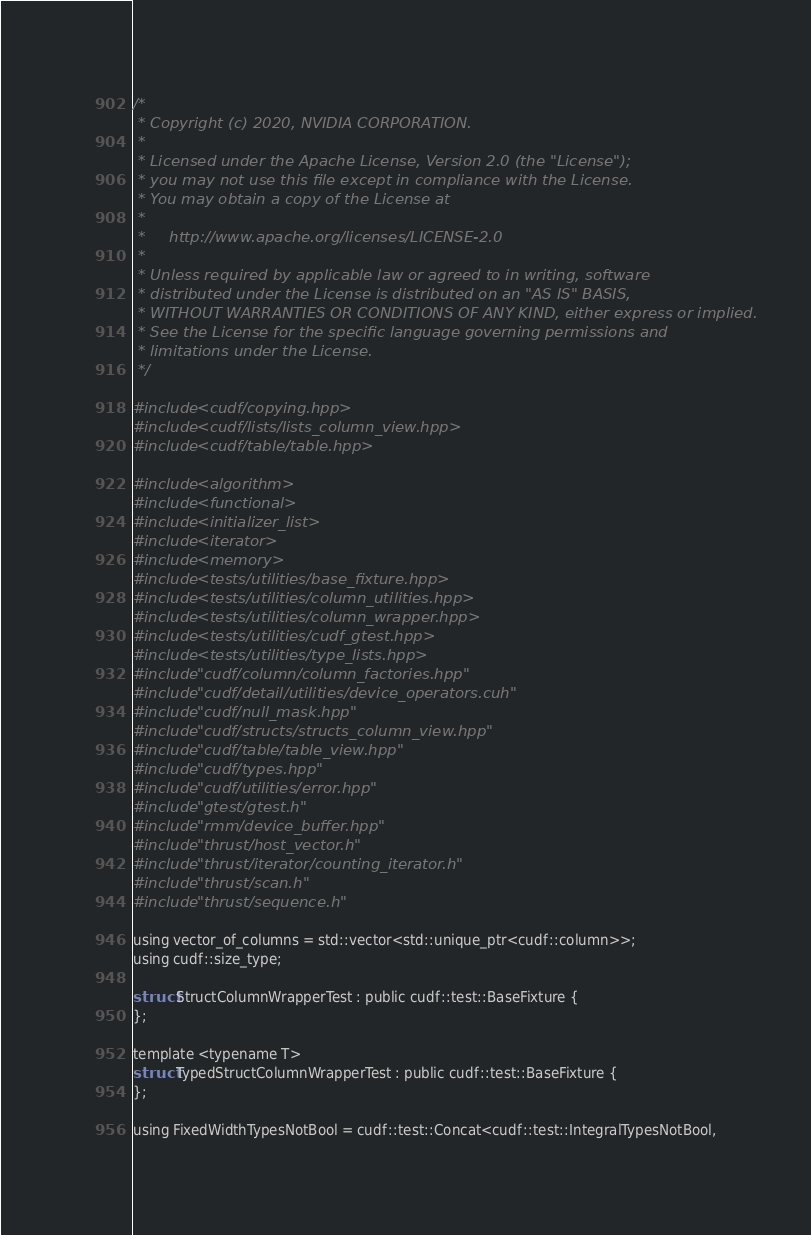Convert code to text. <code><loc_0><loc_0><loc_500><loc_500><_Cuda_>/*
 * Copyright (c) 2020, NVIDIA CORPORATION.
 *
 * Licensed under the Apache License, Version 2.0 (the "License");
 * you may not use this file except in compliance with the License.
 * You may obtain a copy of the License at
 *
 *     http://www.apache.org/licenses/LICENSE-2.0
 *
 * Unless required by applicable law or agreed to in writing, software
 * distributed under the License is distributed on an "AS IS" BASIS,
 * WITHOUT WARRANTIES OR CONDITIONS OF ANY KIND, either express or implied.
 * See the License for the specific language governing permissions and
 * limitations under the License.
 */

#include <cudf/copying.hpp>
#include <cudf/lists/lists_column_view.hpp>
#include <cudf/table/table.hpp>

#include <algorithm>
#include <functional>
#include <initializer_list>
#include <iterator>
#include <memory>
#include <tests/utilities/base_fixture.hpp>
#include <tests/utilities/column_utilities.hpp>
#include <tests/utilities/column_wrapper.hpp>
#include <tests/utilities/cudf_gtest.hpp>
#include <tests/utilities/type_lists.hpp>
#include "cudf/column/column_factories.hpp"
#include "cudf/detail/utilities/device_operators.cuh"
#include "cudf/null_mask.hpp"
#include "cudf/structs/structs_column_view.hpp"
#include "cudf/table/table_view.hpp"
#include "cudf/types.hpp"
#include "cudf/utilities/error.hpp"
#include "gtest/gtest.h"
#include "rmm/device_buffer.hpp"
#include "thrust/host_vector.h"
#include "thrust/iterator/counting_iterator.h"
#include "thrust/scan.h"
#include "thrust/sequence.h"

using vector_of_columns = std::vector<std::unique_ptr<cudf::column>>;
using cudf::size_type;

struct StructColumnWrapperTest : public cudf::test::BaseFixture {
};

template <typename T>
struct TypedStructColumnWrapperTest : public cudf::test::BaseFixture {
};

using FixedWidthTypesNotBool = cudf::test::Concat<cudf::test::IntegralTypesNotBool,</code> 